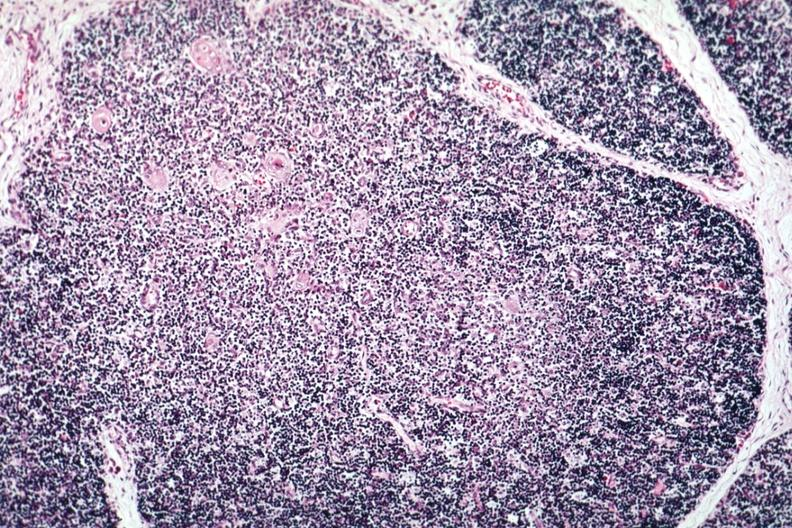s serous cyst present?
Answer the question using a single word or phrase. No 